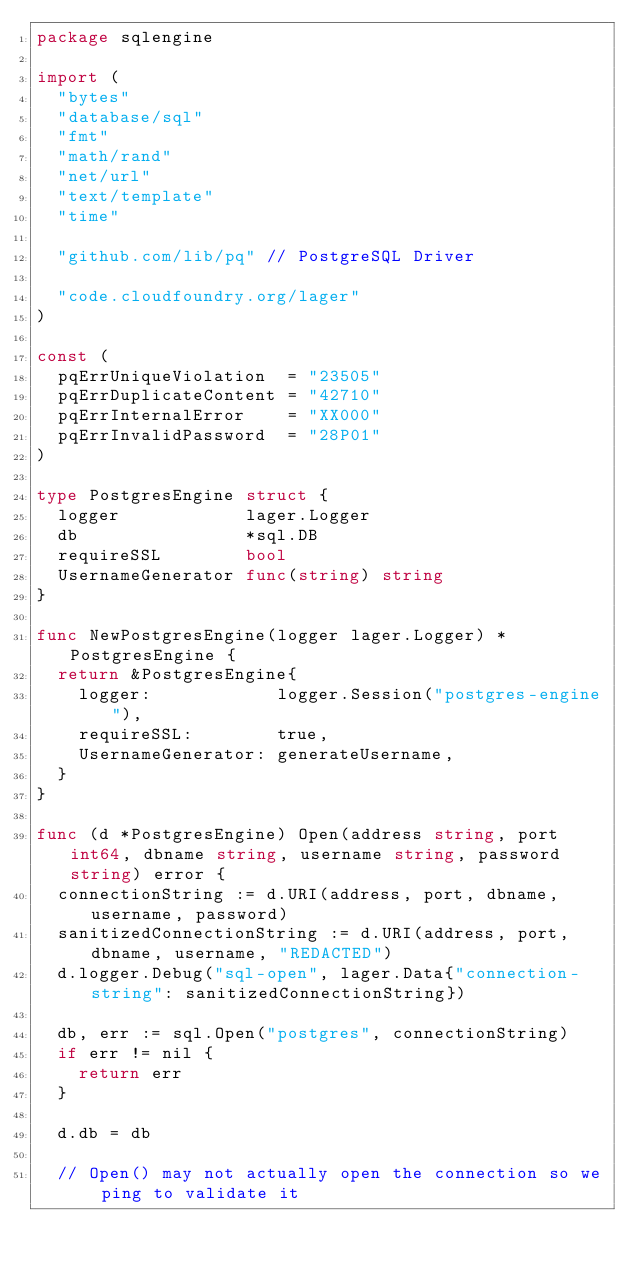Convert code to text. <code><loc_0><loc_0><loc_500><loc_500><_Go_>package sqlengine

import (
	"bytes"
	"database/sql"
	"fmt"
	"math/rand"
	"net/url"
	"text/template"
	"time"

	"github.com/lib/pq" // PostgreSQL Driver

	"code.cloudfoundry.org/lager"
)

const (
	pqErrUniqueViolation  = "23505"
	pqErrDuplicateContent = "42710"
	pqErrInternalError    = "XX000"
	pqErrInvalidPassword  = "28P01"
)

type PostgresEngine struct {
	logger            lager.Logger
	db                *sql.DB
	requireSSL        bool
	UsernameGenerator func(string) string
}

func NewPostgresEngine(logger lager.Logger) *PostgresEngine {
	return &PostgresEngine{
		logger:            logger.Session("postgres-engine"),
		requireSSL:        true,
		UsernameGenerator: generateUsername,
	}
}

func (d *PostgresEngine) Open(address string, port int64, dbname string, username string, password string) error {
	connectionString := d.URI(address, port, dbname, username, password)
	sanitizedConnectionString := d.URI(address, port, dbname, username, "REDACTED")
	d.logger.Debug("sql-open", lager.Data{"connection-string": sanitizedConnectionString})

	db, err := sql.Open("postgres", connectionString)
	if err != nil {
		return err
	}

	d.db = db

	// Open() may not actually open the connection so we ping to validate it</code> 